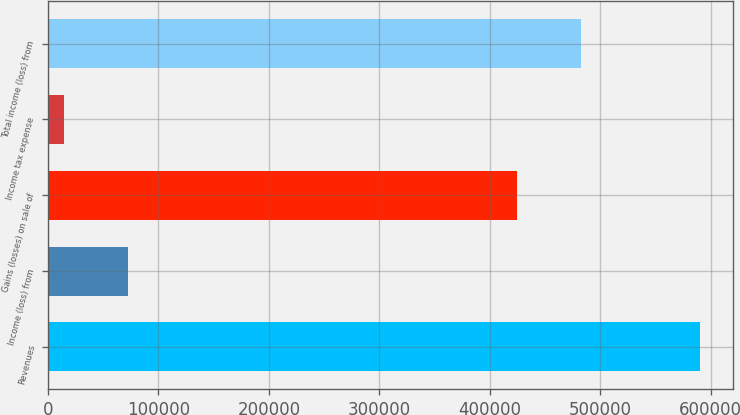Convert chart. <chart><loc_0><loc_0><loc_500><loc_500><bar_chart><fcel>Revenues<fcel>Income (loss) from<fcel>Gains (losses) on sale of<fcel>Income tax expense<fcel>Total income (loss) from<nl><fcel>590688<fcel>72299.7<fcel>424838<fcel>14701<fcel>482437<nl></chart> 